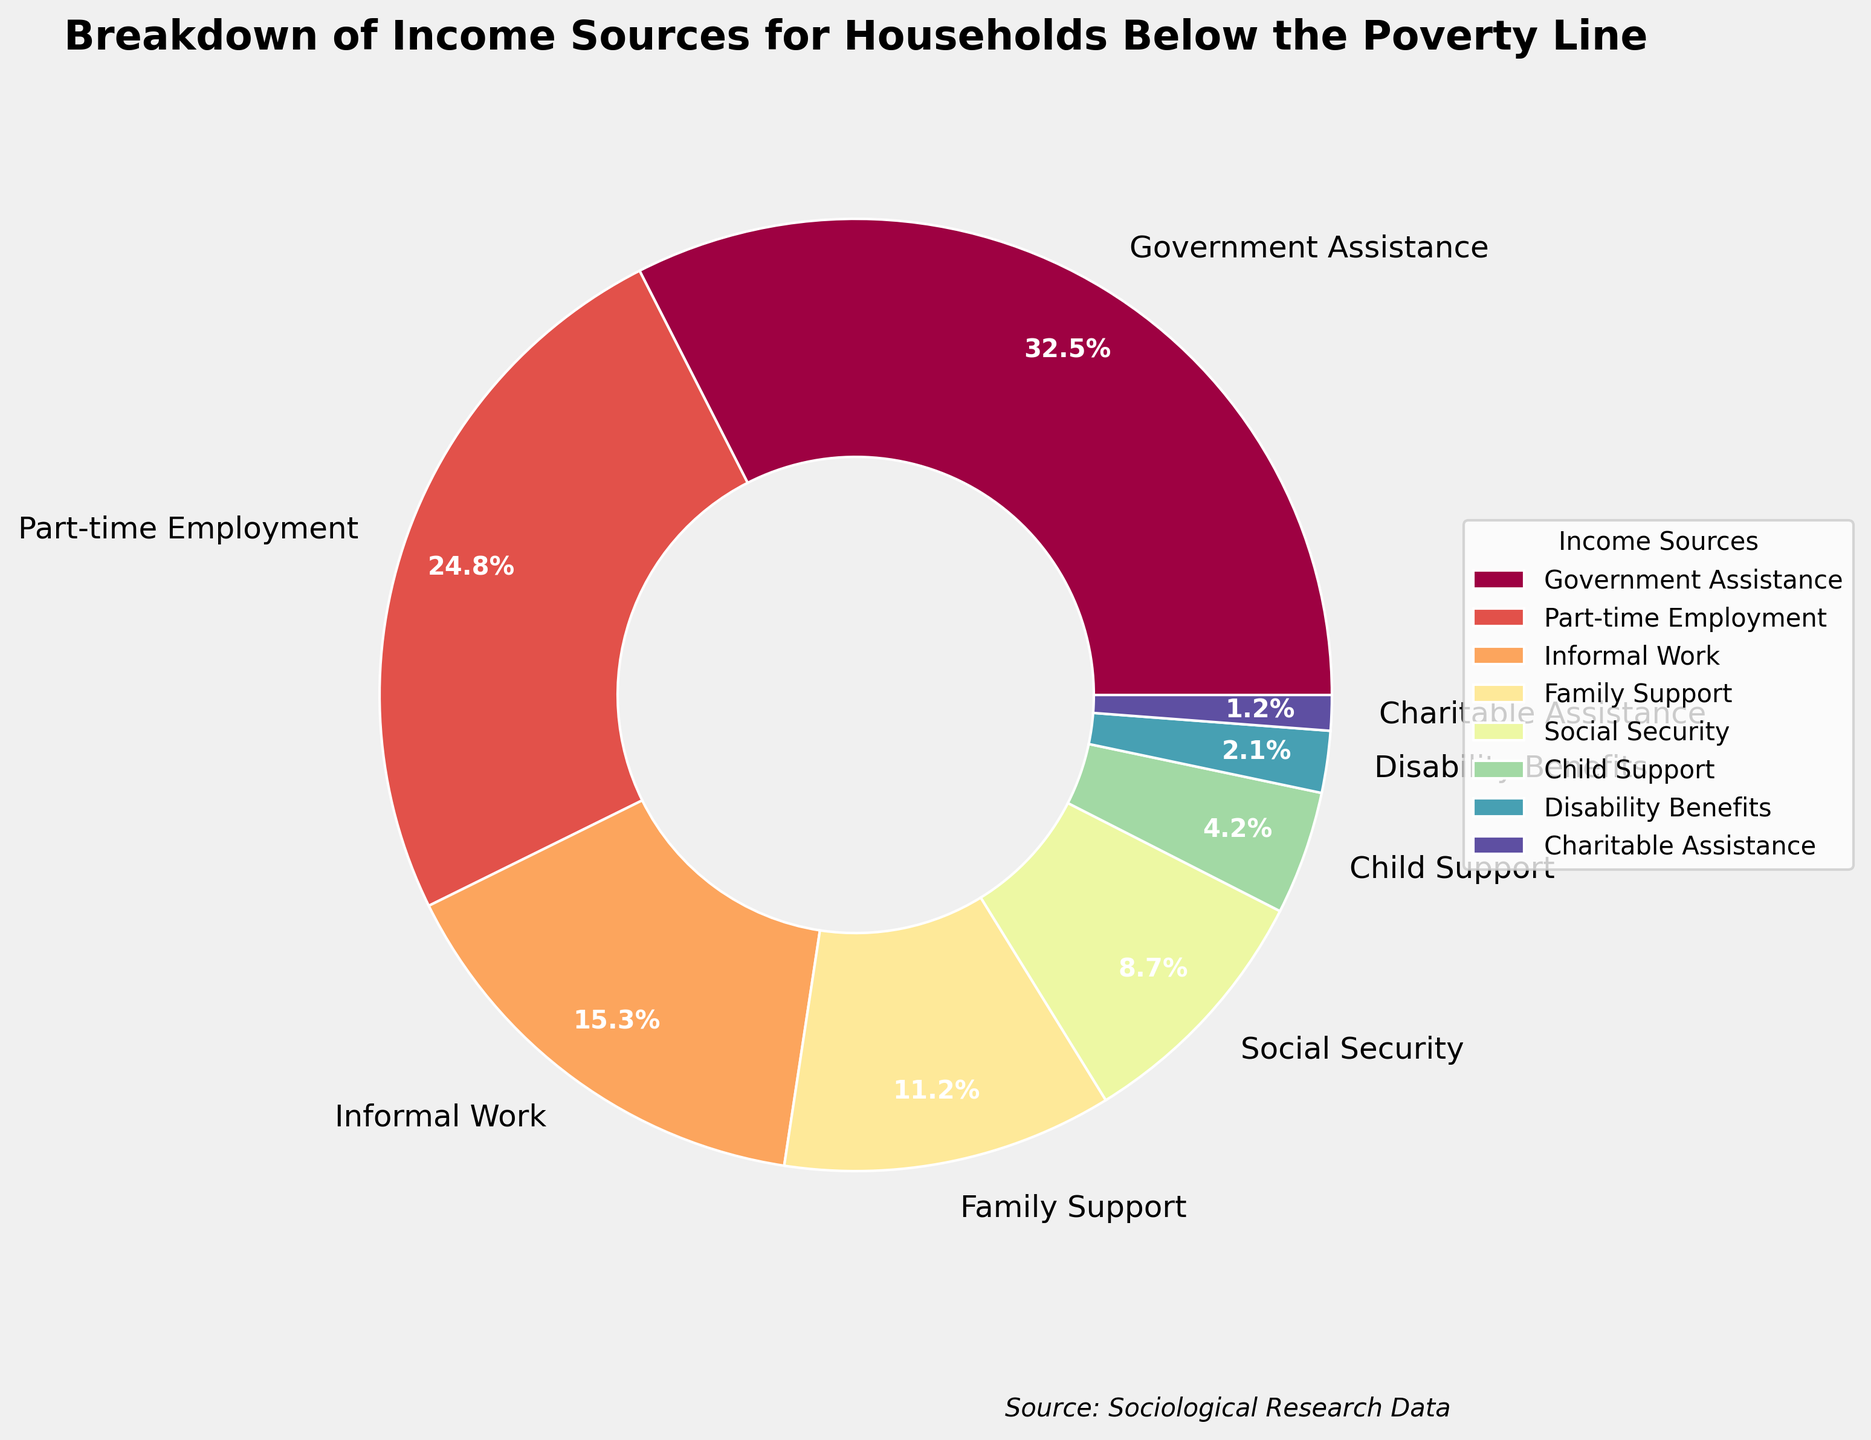what are the top three sources of income for households below the poverty line? The top three sources can be identified by looking at the highest percentages in the pie chart. Government Assistance (32.5%), Part-time Employment (24.8%), and Informal Work (15.3%) have the highest values.
Answer: Government Assistance, Part-time Employment, Informal Work Which income source contributes the least to households below the poverty line? The smallest section of the pie chart represents the income source with the lowest percentage. Charitable Assistance, at 1.2%, is the smallest.
Answer: Charitable Assistance What's the combined percentage of Part-time Employment and Informal Work? To find the combined percentage, add the percentages of Part-time Employment (24.8%) and Informal Work (15.3%). 24.8 + 15.3 = 40.1
Answer: 40.1% How does the percentage of Social Security compare to that of Disability Benefits? By comparing the sizes of the slices for Social Security (8.7%) and Disability Benefits (2.1%), we can see that Social Security has a higher percentage than Disability Benefits.
Answer: Social Security is higher What income sources collectively make up more than 50% of the total? To find the sources that collectively make up more than 50%, we can start from the largest and add their percentages until the sum exceeds 50%. Start with Government Assistance (32.5%), add Part-time Employment (24.8%): 32.5 + 24.8 = 57.3, which is more than 50%.
Answer: Government Assistance, Part-time Employment If the combined percentage of Family Support and Social Security were to increase by 2%, what would the new combined percentage be? The current combined percentage of Family Support (11.2%) and Social Security (8.7%) is 11.2 + 8.7 = 19.9. Increasing this by 2% results in 19.9 + 2 = 21.9%.
Answer: 21.9% Which income source has a visual color closest to red? By referring to the pie chart colors, Government Assistance is represented by a color closest to red.
Answer: Government Assistance Is Part-time Employment or Informal Work a greater source of income, and by how much? Part-time Employment is 24.8% and Informal Work is 15.3%. Subtract 15.3% from 24.8% to find the difference, 24.8 - 15.3 = 9.5%.
Answer: Part-time Employment by 9.5% What is the median percentage value for all income sources? To find the median, list all percentages in ascending order: 1.2, 2.1, 4.2, 8.7, 11.2, 15.3, 24.8, 32.5. With 8 data points, the median is the average of the 4th and 5th values: (8.7 + 11.2)/2 = 9.95.
Answer: 9.95% 